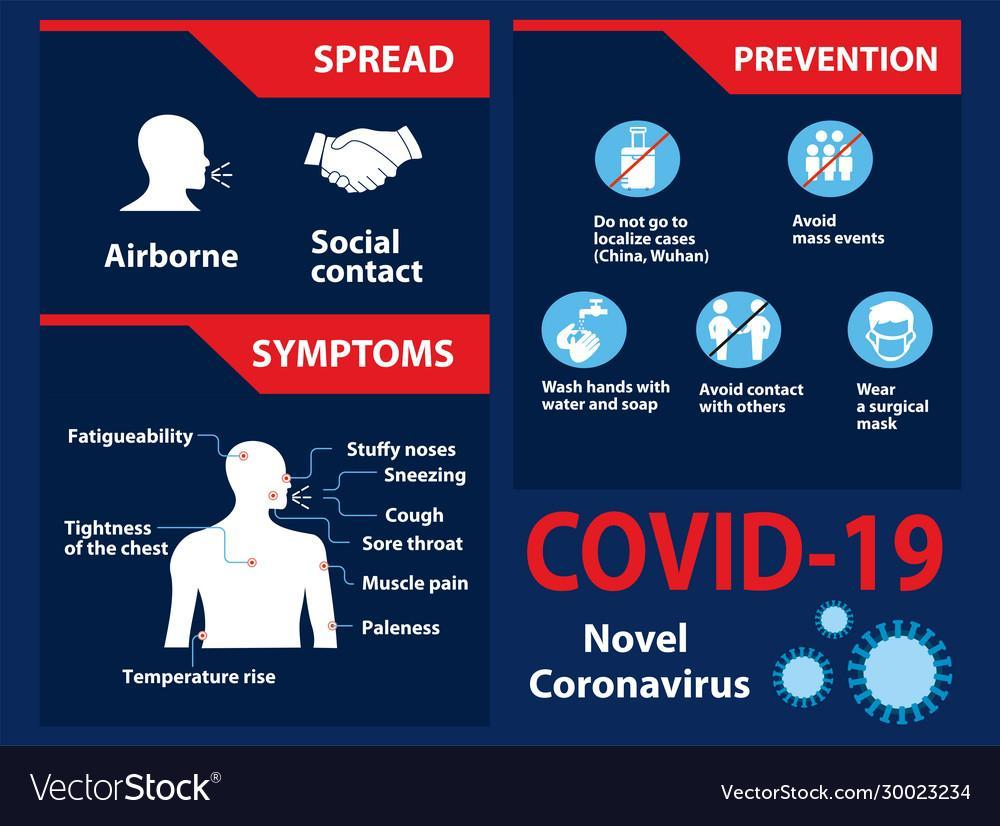How does the coronavirus disease spread?
Answer the question with a short phrase. Airborne, Social contact How many don't are mentioned in the prevention measures of the COVID-19? 3 